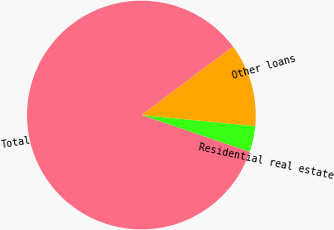<chart> <loc_0><loc_0><loc_500><loc_500><pie_chart><fcel>Residential real estate<fcel>Other loans<fcel>Total<nl><fcel>3.68%<fcel>11.77%<fcel>84.55%<nl></chart> 